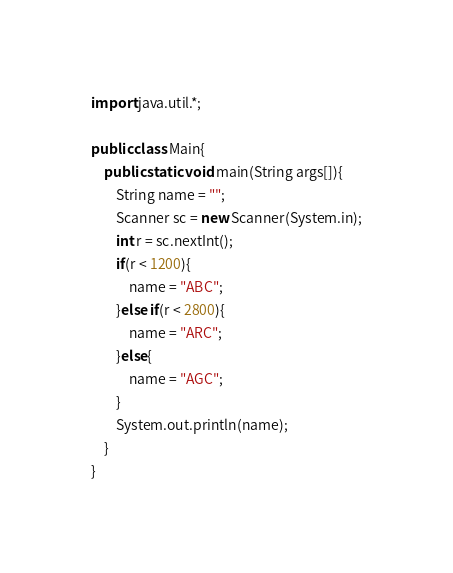<code> <loc_0><loc_0><loc_500><loc_500><_Java_>import java.util.*;

public class Main{
    public static void main(String args[]){
        String name = "";
        Scanner sc = new Scanner(System.in);
        int r = sc.nextInt();
        if(r < 1200){
            name = "ABC";
        }else if(r < 2800){
            name = "ARC";
        }else{
            name = "AGC";
        }
        System.out.println(name);
    }
}</code> 